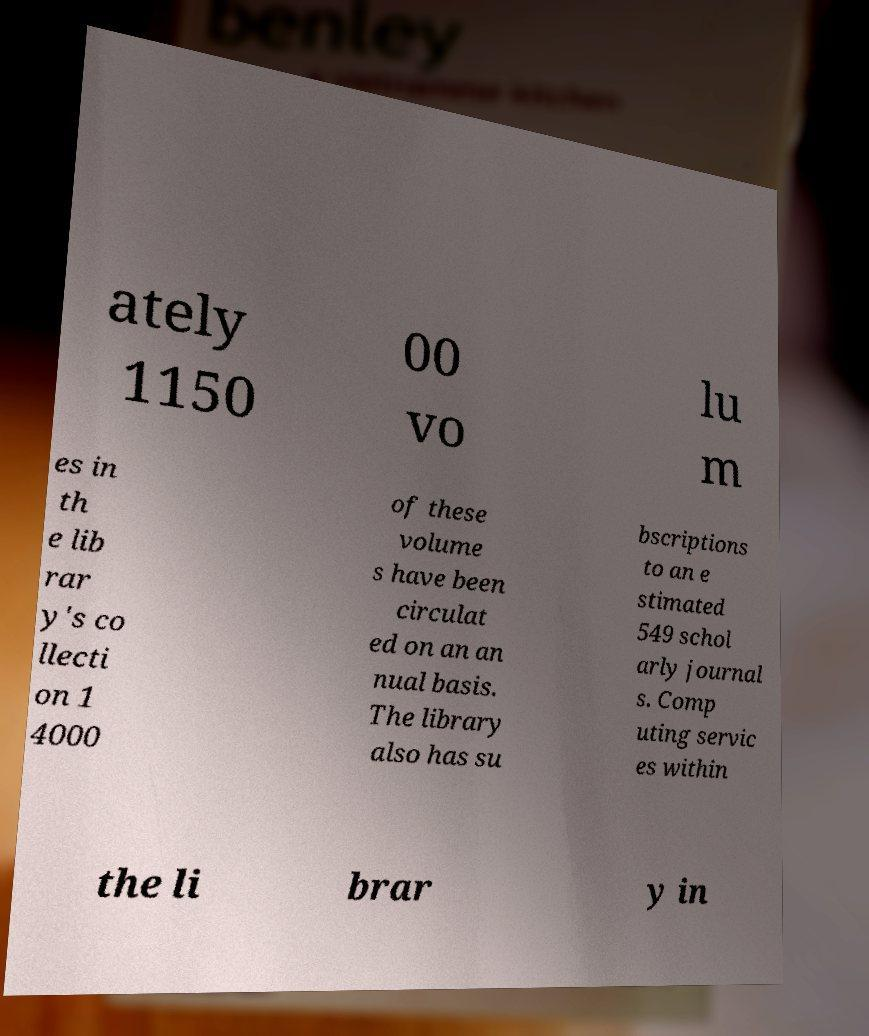I need the written content from this picture converted into text. Can you do that? ately 1150 00 vo lu m es in th e lib rar y's co llecti on 1 4000 of these volume s have been circulat ed on an an nual basis. The library also has su bscriptions to an e stimated 549 schol arly journal s. Comp uting servic es within the li brar y in 